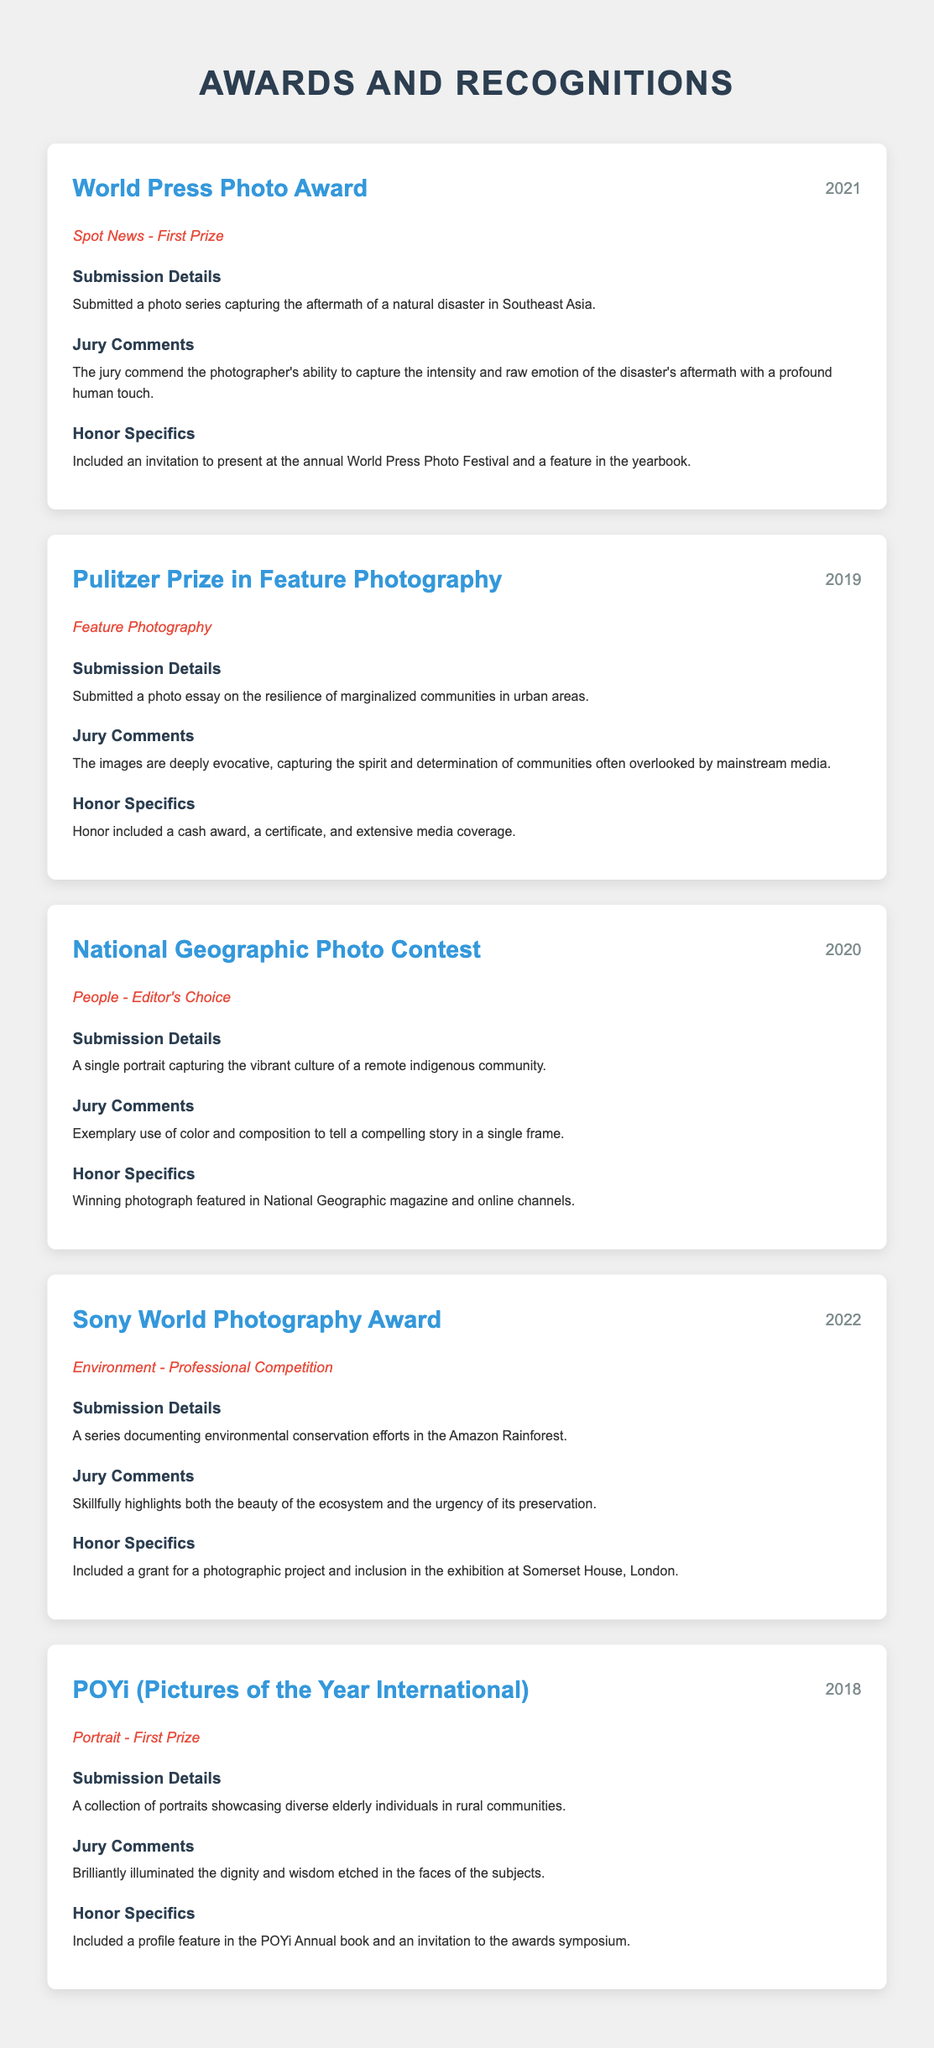What award did you win in 2021? The document states that the award won in 2021 was the "World Press Photo Award."
Answer: World Press Photo Award What category did you receive in the Pulitzer Prize? The document mentions that the Pulitzer Prize was awarded in the "Feature Photography" category.
Answer: Feature Photography In which year did you receive the National Geographic Editor's Choice award? The document indicates that the National Geographic Photo Contest was won in 2020.
Answer: 2020 What was highlighted in the jury comments for the Sony World Photography Award? It is noted in the document that the jury commented on the skillful highlighting of "both the beauty of the ecosystem and the urgency of its preservation."
Answer: beauty of the ecosystem and the urgency of its preservation What type of photographs were submitted for the POYi award? The document specifies that the photographs submitted for the POYi award were "portraits showcasing diverse elderly individuals in rural communities."
Answer: portraits showcasing diverse elderly individuals in rural communities What was one of the honors received for the World Press Photo Award? The document states that one of the honors included "an invitation to present at the annual World Press Photo Festival."
Answer: invitation to present at the annual World Press Photo Festival How many awards are listed in the document? The document lists a total of five distinct awards received.
Answer: Five In what category was the award received in 2022? The document specifies that the award received in 2022 was in the "Environment - Professional Competition" category.
Answer: Environment - Professional Competition 